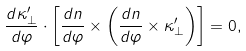<formula> <loc_0><loc_0><loc_500><loc_500>\frac { d \kappa ^ { \prime } _ { \perp } } { d \varphi } \cdot \left [ \frac { d n } { d \varphi } \times \left ( \frac { d n } { d \varphi } \times \kappa ^ { \prime } _ { \perp } \right ) \right ] = 0 ,</formula> 